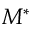Convert formula to latex. <formula><loc_0><loc_0><loc_500><loc_500>M ^ { * }</formula> 